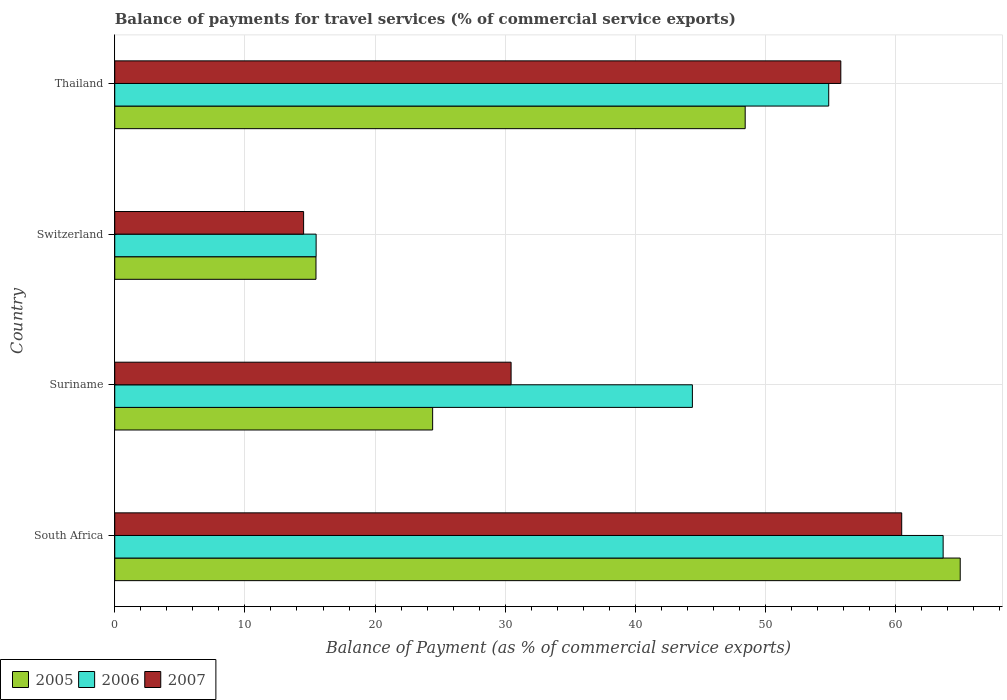How many different coloured bars are there?
Provide a succinct answer. 3. Are the number of bars on each tick of the Y-axis equal?
Your response must be concise. Yes. How many bars are there on the 2nd tick from the top?
Offer a terse response. 3. What is the label of the 3rd group of bars from the top?
Give a very brief answer. Suriname. In how many cases, is the number of bars for a given country not equal to the number of legend labels?
Offer a terse response. 0. What is the balance of payments for travel services in 2005 in Suriname?
Your response must be concise. 24.42. Across all countries, what is the maximum balance of payments for travel services in 2005?
Provide a succinct answer. 64.96. Across all countries, what is the minimum balance of payments for travel services in 2007?
Your answer should be compact. 14.51. In which country was the balance of payments for travel services in 2005 maximum?
Provide a short and direct response. South Africa. In which country was the balance of payments for travel services in 2006 minimum?
Your answer should be compact. Switzerland. What is the total balance of payments for travel services in 2005 in the graph?
Your response must be concise. 153.29. What is the difference between the balance of payments for travel services in 2007 in Suriname and that in Switzerland?
Give a very brief answer. 15.94. What is the difference between the balance of payments for travel services in 2006 in Thailand and the balance of payments for travel services in 2007 in Suriname?
Your response must be concise. 24.4. What is the average balance of payments for travel services in 2006 per country?
Provide a short and direct response. 44.59. What is the difference between the balance of payments for travel services in 2005 and balance of payments for travel services in 2007 in Thailand?
Your answer should be compact. -7.35. In how many countries, is the balance of payments for travel services in 2005 greater than 54 %?
Offer a very short reply. 1. What is the ratio of the balance of payments for travel services in 2005 in South Africa to that in Suriname?
Provide a succinct answer. 2.66. Is the difference between the balance of payments for travel services in 2005 in South Africa and Switzerland greater than the difference between the balance of payments for travel services in 2007 in South Africa and Switzerland?
Keep it short and to the point. Yes. What is the difference between the highest and the second highest balance of payments for travel services in 2006?
Provide a short and direct response. 8.79. What is the difference between the highest and the lowest balance of payments for travel services in 2005?
Ensure brevity in your answer.  49.5. In how many countries, is the balance of payments for travel services in 2006 greater than the average balance of payments for travel services in 2006 taken over all countries?
Give a very brief answer. 2. Is the sum of the balance of payments for travel services in 2006 in South Africa and Switzerland greater than the maximum balance of payments for travel services in 2007 across all countries?
Offer a terse response. Yes. What does the 1st bar from the top in Suriname represents?
Provide a succinct answer. 2007. What does the 1st bar from the bottom in Switzerland represents?
Provide a short and direct response. 2005. Is it the case that in every country, the sum of the balance of payments for travel services in 2006 and balance of payments for travel services in 2005 is greater than the balance of payments for travel services in 2007?
Give a very brief answer. Yes. How many bars are there?
Your answer should be compact. 12. Are all the bars in the graph horizontal?
Your answer should be compact. Yes. What is the difference between two consecutive major ticks on the X-axis?
Offer a very short reply. 10. Does the graph contain grids?
Give a very brief answer. Yes. Where does the legend appear in the graph?
Provide a succinct answer. Bottom left. How many legend labels are there?
Offer a very short reply. 3. What is the title of the graph?
Provide a succinct answer. Balance of payments for travel services (% of commercial service exports). What is the label or title of the X-axis?
Your answer should be very brief. Balance of Payment (as % of commercial service exports). What is the label or title of the Y-axis?
Ensure brevity in your answer.  Country. What is the Balance of Payment (as % of commercial service exports) of 2005 in South Africa?
Provide a short and direct response. 64.96. What is the Balance of Payment (as % of commercial service exports) of 2006 in South Africa?
Offer a terse response. 63.65. What is the Balance of Payment (as % of commercial service exports) in 2007 in South Africa?
Keep it short and to the point. 60.46. What is the Balance of Payment (as % of commercial service exports) of 2005 in Suriname?
Your answer should be very brief. 24.42. What is the Balance of Payment (as % of commercial service exports) in 2006 in Suriname?
Ensure brevity in your answer.  44.38. What is the Balance of Payment (as % of commercial service exports) in 2007 in Suriname?
Ensure brevity in your answer.  30.45. What is the Balance of Payment (as % of commercial service exports) in 2005 in Switzerland?
Provide a short and direct response. 15.46. What is the Balance of Payment (as % of commercial service exports) in 2006 in Switzerland?
Your answer should be compact. 15.47. What is the Balance of Payment (as % of commercial service exports) of 2007 in Switzerland?
Keep it short and to the point. 14.51. What is the Balance of Payment (as % of commercial service exports) of 2005 in Thailand?
Offer a terse response. 48.44. What is the Balance of Payment (as % of commercial service exports) of 2006 in Thailand?
Give a very brief answer. 54.86. What is the Balance of Payment (as % of commercial service exports) of 2007 in Thailand?
Offer a very short reply. 55.79. Across all countries, what is the maximum Balance of Payment (as % of commercial service exports) in 2005?
Your response must be concise. 64.96. Across all countries, what is the maximum Balance of Payment (as % of commercial service exports) in 2006?
Keep it short and to the point. 63.65. Across all countries, what is the maximum Balance of Payment (as % of commercial service exports) of 2007?
Give a very brief answer. 60.46. Across all countries, what is the minimum Balance of Payment (as % of commercial service exports) of 2005?
Your answer should be very brief. 15.46. Across all countries, what is the minimum Balance of Payment (as % of commercial service exports) of 2006?
Keep it short and to the point. 15.47. Across all countries, what is the minimum Balance of Payment (as % of commercial service exports) in 2007?
Give a very brief answer. 14.51. What is the total Balance of Payment (as % of commercial service exports) in 2005 in the graph?
Your answer should be very brief. 153.29. What is the total Balance of Payment (as % of commercial service exports) of 2006 in the graph?
Offer a terse response. 178.36. What is the total Balance of Payment (as % of commercial service exports) in 2007 in the graph?
Provide a succinct answer. 161.22. What is the difference between the Balance of Payment (as % of commercial service exports) in 2005 in South Africa and that in Suriname?
Your response must be concise. 40.54. What is the difference between the Balance of Payment (as % of commercial service exports) in 2006 in South Africa and that in Suriname?
Provide a succinct answer. 19.27. What is the difference between the Balance of Payment (as % of commercial service exports) of 2007 in South Africa and that in Suriname?
Provide a short and direct response. 30.01. What is the difference between the Balance of Payment (as % of commercial service exports) in 2005 in South Africa and that in Switzerland?
Ensure brevity in your answer.  49.5. What is the difference between the Balance of Payment (as % of commercial service exports) in 2006 in South Africa and that in Switzerland?
Provide a short and direct response. 48.18. What is the difference between the Balance of Payment (as % of commercial service exports) of 2007 in South Africa and that in Switzerland?
Your response must be concise. 45.95. What is the difference between the Balance of Payment (as % of commercial service exports) in 2005 in South Africa and that in Thailand?
Provide a succinct answer. 16.52. What is the difference between the Balance of Payment (as % of commercial service exports) of 2006 in South Africa and that in Thailand?
Give a very brief answer. 8.79. What is the difference between the Balance of Payment (as % of commercial service exports) in 2007 in South Africa and that in Thailand?
Your answer should be compact. 4.68. What is the difference between the Balance of Payment (as % of commercial service exports) in 2005 in Suriname and that in Switzerland?
Offer a very short reply. 8.96. What is the difference between the Balance of Payment (as % of commercial service exports) of 2006 in Suriname and that in Switzerland?
Provide a succinct answer. 28.91. What is the difference between the Balance of Payment (as % of commercial service exports) in 2007 in Suriname and that in Switzerland?
Offer a very short reply. 15.94. What is the difference between the Balance of Payment (as % of commercial service exports) of 2005 in Suriname and that in Thailand?
Offer a terse response. -24.01. What is the difference between the Balance of Payment (as % of commercial service exports) of 2006 in Suriname and that in Thailand?
Offer a terse response. -10.48. What is the difference between the Balance of Payment (as % of commercial service exports) of 2007 in Suriname and that in Thailand?
Make the answer very short. -25.33. What is the difference between the Balance of Payment (as % of commercial service exports) of 2005 in Switzerland and that in Thailand?
Make the answer very short. -32.98. What is the difference between the Balance of Payment (as % of commercial service exports) of 2006 in Switzerland and that in Thailand?
Your response must be concise. -39.39. What is the difference between the Balance of Payment (as % of commercial service exports) of 2007 in Switzerland and that in Thailand?
Your response must be concise. -41.28. What is the difference between the Balance of Payment (as % of commercial service exports) in 2005 in South Africa and the Balance of Payment (as % of commercial service exports) in 2006 in Suriname?
Provide a short and direct response. 20.58. What is the difference between the Balance of Payment (as % of commercial service exports) of 2005 in South Africa and the Balance of Payment (as % of commercial service exports) of 2007 in Suriname?
Give a very brief answer. 34.51. What is the difference between the Balance of Payment (as % of commercial service exports) of 2006 in South Africa and the Balance of Payment (as % of commercial service exports) of 2007 in Suriname?
Make the answer very short. 33.2. What is the difference between the Balance of Payment (as % of commercial service exports) in 2005 in South Africa and the Balance of Payment (as % of commercial service exports) in 2006 in Switzerland?
Offer a terse response. 49.49. What is the difference between the Balance of Payment (as % of commercial service exports) in 2005 in South Africa and the Balance of Payment (as % of commercial service exports) in 2007 in Switzerland?
Make the answer very short. 50.45. What is the difference between the Balance of Payment (as % of commercial service exports) of 2006 in South Africa and the Balance of Payment (as % of commercial service exports) of 2007 in Switzerland?
Offer a terse response. 49.14. What is the difference between the Balance of Payment (as % of commercial service exports) of 2005 in South Africa and the Balance of Payment (as % of commercial service exports) of 2006 in Thailand?
Your response must be concise. 10.1. What is the difference between the Balance of Payment (as % of commercial service exports) of 2005 in South Africa and the Balance of Payment (as % of commercial service exports) of 2007 in Thailand?
Give a very brief answer. 9.17. What is the difference between the Balance of Payment (as % of commercial service exports) of 2006 in South Africa and the Balance of Payment (as % of commercial service exports) of 2007 in Thailand?
Provide a short and direct response. 7.86. What is the difference between the Balance of Payment (as % of commercial service exports) of 2005 in Suriname and the Balance of Payment (as % of commercial service exports) of 2006 in Switzerland?
Your answer should be very brief. 8.95. What is the difference between the Balance of Payment (as % of commercial service exports) in 2005 in Suriname and the Balance of Payment (as % of commercial service exports) in 2007 in Switzerland?
Give a very brief answer. 9.91. What is the difference between the Balance of Payment (as % of commercial service exports) in 2006 in Suriname and the Balance of Payment (as % of commercial service exports) in 2007 in Switzerland?
Offer a very short reply. 29.87. What is the difference between the Balance of Payment (as % of commercial service exports) of 2005 in Suriname and the Balance of Payment (as % of commercial service exports) of 2006 in Thailand?
Your answer should be very brief. -30.43. What is the difference between the Balance of Payment (as % of commercial service exports) of 2005 in Suriname and the Balance of Payment (as % of commercial service exports) of 2007 in Thailand?
Give a very brief answer. -31.36. What is the difference between the Balance of Payment (as % of commercial service exports) in 2006 in Suriname and the Balance of Payment (as % of commercial service exports) in 2007 in Thailand?
Your answer should be very brief. -11.4. What is the difference between the Balance of Payment (as % of commercial service exports) in 2005 in Switzerland and the Balance of Payment (as % of commercial service exports) in 2006 in Thailand?
Provide a short and direct response. -39.4. What is the difference between the Balance of Payment (as % of commercial service exports) of 2005 in Switzerland and the Balance of Payment (as % of commercial service exports) of 2007 in Thailand?
Your answer should be very brief. -40.33. What is the difference between the Balance of Payment (as % of commercial service exports) of 2006 in Switzerland and the Balance of Payment (as % of commercial service exports) of 2007 in Thailand?
Keep it short and to the point. -40.31. What is the average Balance of Payment (as % of commercial service exports) in 2005 per country?
Offer a very short reply. 38.32. What is the average Balance of Payment (as % of commercial service exports) in 2006 per country?
Provide a short and direct response. 44.59. What is the average Balance of Payment (as % of commercial service exports) in 2007 per country?
Make the answer very short. 40.3. What is the difference between the Balance of Payment (as % of commercial service exports) in 2005 and Balance of Payment (as % of commercial service exports) in 2006 in South Africa?
Your response must be concise. 1.31. What is the difference between the Balance of Payment (as % of commercial service exports) of 2005 and Balance of Payment (as % of commercial service exports) of 2007 in South Africa?
Offer a terse response. 4.5. What is the difference between the Balance of Payment (as % of commercial service exports) in 2006 and Balance of Payment (as % of commercial service exports) in 2007 in South Africa?
Ensure brevity in your answer.  3.18. What is the difference between the Balance of Payment (as % of commercial service exports) of 2005 and Balance of Payment (as % of commercial service exports) of 2006 in Suriname?
Your answer should be compact. -19.96. What is the difference between the Balance of Payment (as % of commercial service exports) in 2005 and Balance of Payment (as % of commercial service exports) in 2007 in Suriname?
Give a very brief answer. -6.03. What is the difference between the Balance of Payment (as % of commercial service exports) in 2006 and Balance of Payment (as % of commercial service exports) in 2007 in Suriname?
Your answer should be very brief. 13.93. What is the difference between the Balance of Payment (as % of commercial service exports) of 2005 and Balance of Payment (as % of commercial service exports) of 2006 in Switzerland?
Keep it short and to the point. -0.01. What is the difference between the Balance of Payment (as % of commercial service exports) of 2005 and Balance of Payment (as % of commercial service exports) of 2007 in Switzerland?
Your answer should be very brief. 0.95. What is the difference between the Balance of Payment (as % of commercial service exports) in 2006 and Balance of Payment (as % of commercial service exports) in 2007 in Switzerland?
Provide a succinct answer. 0.96. What is the difference between the Balance of Payment (as % of commercial service exports) of 2005 and Balance of Payment (as % of commercial service exports) of 2006 in Thailand?
Keep it short and to the point. -6.42. What is the difference between the Balance of Payment (as % of commercial service exports) of 2005 and Balance of Payment (as % of commercial service exports) of 2007 in Thailand?
Keep it short and to the point. -7.35. What is the difference between the Balance of Payment (as % of commercial service exports) of 2006 and Balance of Payment (as % of commercial service exports) of 2007 in Thailand?
Your response must be concise. -0.93. What is the ratio of the Balance of Payment (as % of commercial service exports) in 2005 in South Africa to that in Suriname?
Your answer should be compact. 2.66. What is the ratio of the Balance of Payment (as % of commercial service exports) in 2006 in South Africa to that in Suriname?
Give a very brief answer. 1.43. What is the ratio of the Balance of Payment (as % of commercial service exports) in 2007 in South Africa to that in Suriname?
Your answer should be very brief. 1.99. What is the ratio of the Balance of Payment (as % of commercial service exports) of 2005 in South Africa to that in Switzerland?
Ensure brevity in your answer.  4.2. What is the ratio of the Balance of Payment (as % of commercial service exports) in 2006 in South Africa to that in Switzerland?
Give a very brief answer. 4.11. What is the ratio of the Balance of Payment (as % of commercial service exports) in 2007 in South Africa to that in Switzerland?
Offer a terse response. 4.17. What is the ratio of the Balance of Payment (as % of commercial service exports) of 2005 in South Africa to that in Thailand?
Your answer should be compact. 1.34. What is the ratio of the Balance of Payment (as % of commercial service exports) of 2006 in South Africa to that in Thailand?
Your answer should be compact. 1.16. What is the ratio of the Balance of Payment (as % of commercial service exports) of 2007 in South Africa to that in Thailand?
Offer a very short reply. 1.08. What is the ratio of the Balance of Payment (as % of commercial service exports) in 2005 in Suriname to that in Switzerland?
Your response must be concise. 1.58. What is the ratio of the Balance of Payment (as % of commercial service exports) in 2006 in Suriname to that in Switzerland?
Offer a very short reply. 2.87. What is the ratio of the Balance of Payment (as % of commercial service exports) of 2007 in Suriname to that in Switzerland?
Make the answer very short. 2.1. What is the ratio of the Balance of Payment (as % of commercial service exports) in 2005 in Suriname to that in Thailand?
Offer a terse response. 0.5. What is the ratio of the Balance of Payment (as % of commercial service exports) of 2006 in Suriname to that in Thailand?
Offer a terse response. 0.81. What is the ratio of the Balance of Payment (as % of commercial service exports) of 2007 in Suriname to that in Thailand?
Ensure brevity in your answer.  0.55. What is the ratio of the Balance of Payment (as % of commercial service exports) in 2005 in Switzerland to that in Thailand?
Ensure brevity in your answer.  0.32. What is the ratio of the Balance of Payment (as % of commercial service exports) of 2006 in Switzerland to that in Thailand?
Give a very brief answer. 0.28. What is the ratio of the Balance of Payment (as % of commercial service exports) in 2007 in Switzerland to that in Thailand?
Your answer should be very brief. 0.26. What is the difference between the highest and the second highest Balance of Payment (as % of commercial service exports) of 2005?
Your response must be concise. 16.52. What is the difference between the highest and the second highest Balance of Payment (as % of commercial service exports) in 2006?
Keep it short and to the point. 8.79. What is the difference between the highest and the second highest Balance of Payment (as % of commercial service exports) of 2007?
Provide a succinct answer. 4.68. What is the difference between the highest and the lowest Balance of Payment (as % of commercial service exports) in 2005?
Provide a succinct answer. 49.5. What is the difference between the highest and the lowest Balance of Payment (as % of commercial service exports) of 2006?
Offer a very short reply. 48.18. What is the difference between the highest and the lowest Balance of Payment (as % of commercial service exports) of 2007?
Your answer should be very brief. 45.95. 